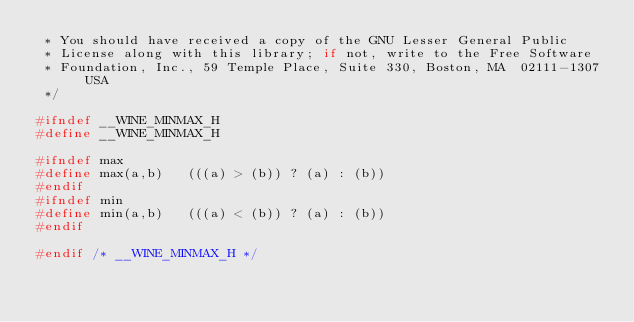Convert code to text. <code><loc_0><loc_0><loc_500><loc_500><_C_> * You should have received a copy of the GNU Lesser General Public
 * License along with this library; if not, write to the Free Software
 * Foundation, Inc., 59 Temple Place, Suite 330, Boston, MA  02111-1307  USA
 */

#ifndef __WINE_MINMAX_H
#define __WINE_MINMAX_H

#ifndef max
#define max(a,b)   (((a) > (b)) ? (a) : (b))
#endif
#ifndef min
#define min(a,b)   (((a) < (b)) ? (a) : (b))
#endif

#endif /* __WINE_MINMAX_H */
</code> 